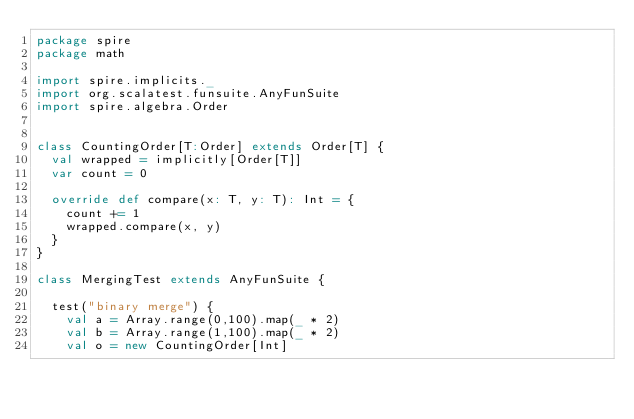Convert code to text. <code><loc_0><loc_0><loc_500><loc_500><_Scala_>package spire
package math

import spire.implicits._
import org.scalatest.funsuite.AnyFunSuite
import spire.algebra.Order


class CountingOrder[T:Order] extends Order[T] {
  val wrapped = implicitly[Order[T]]
  var count = 0

  override def compare(x: T, y: T): Int = {
    count += 1
    wrapped.compare(x, y)
  }
}

class MergingTest extends AnyFunSuite {

  test("binary merge") {
    val a = Array.range(0,100).map(_ * 2)
    val b = Array.range(1,100).map(_ * 2)
    val o = new CountingOrder[Int]</code> 